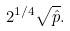<formula> <loc_0><loc_0><loc_500><loc_500>2 ^ { 1 / 4 } \sqrt { \hat { p } } .</formula> 